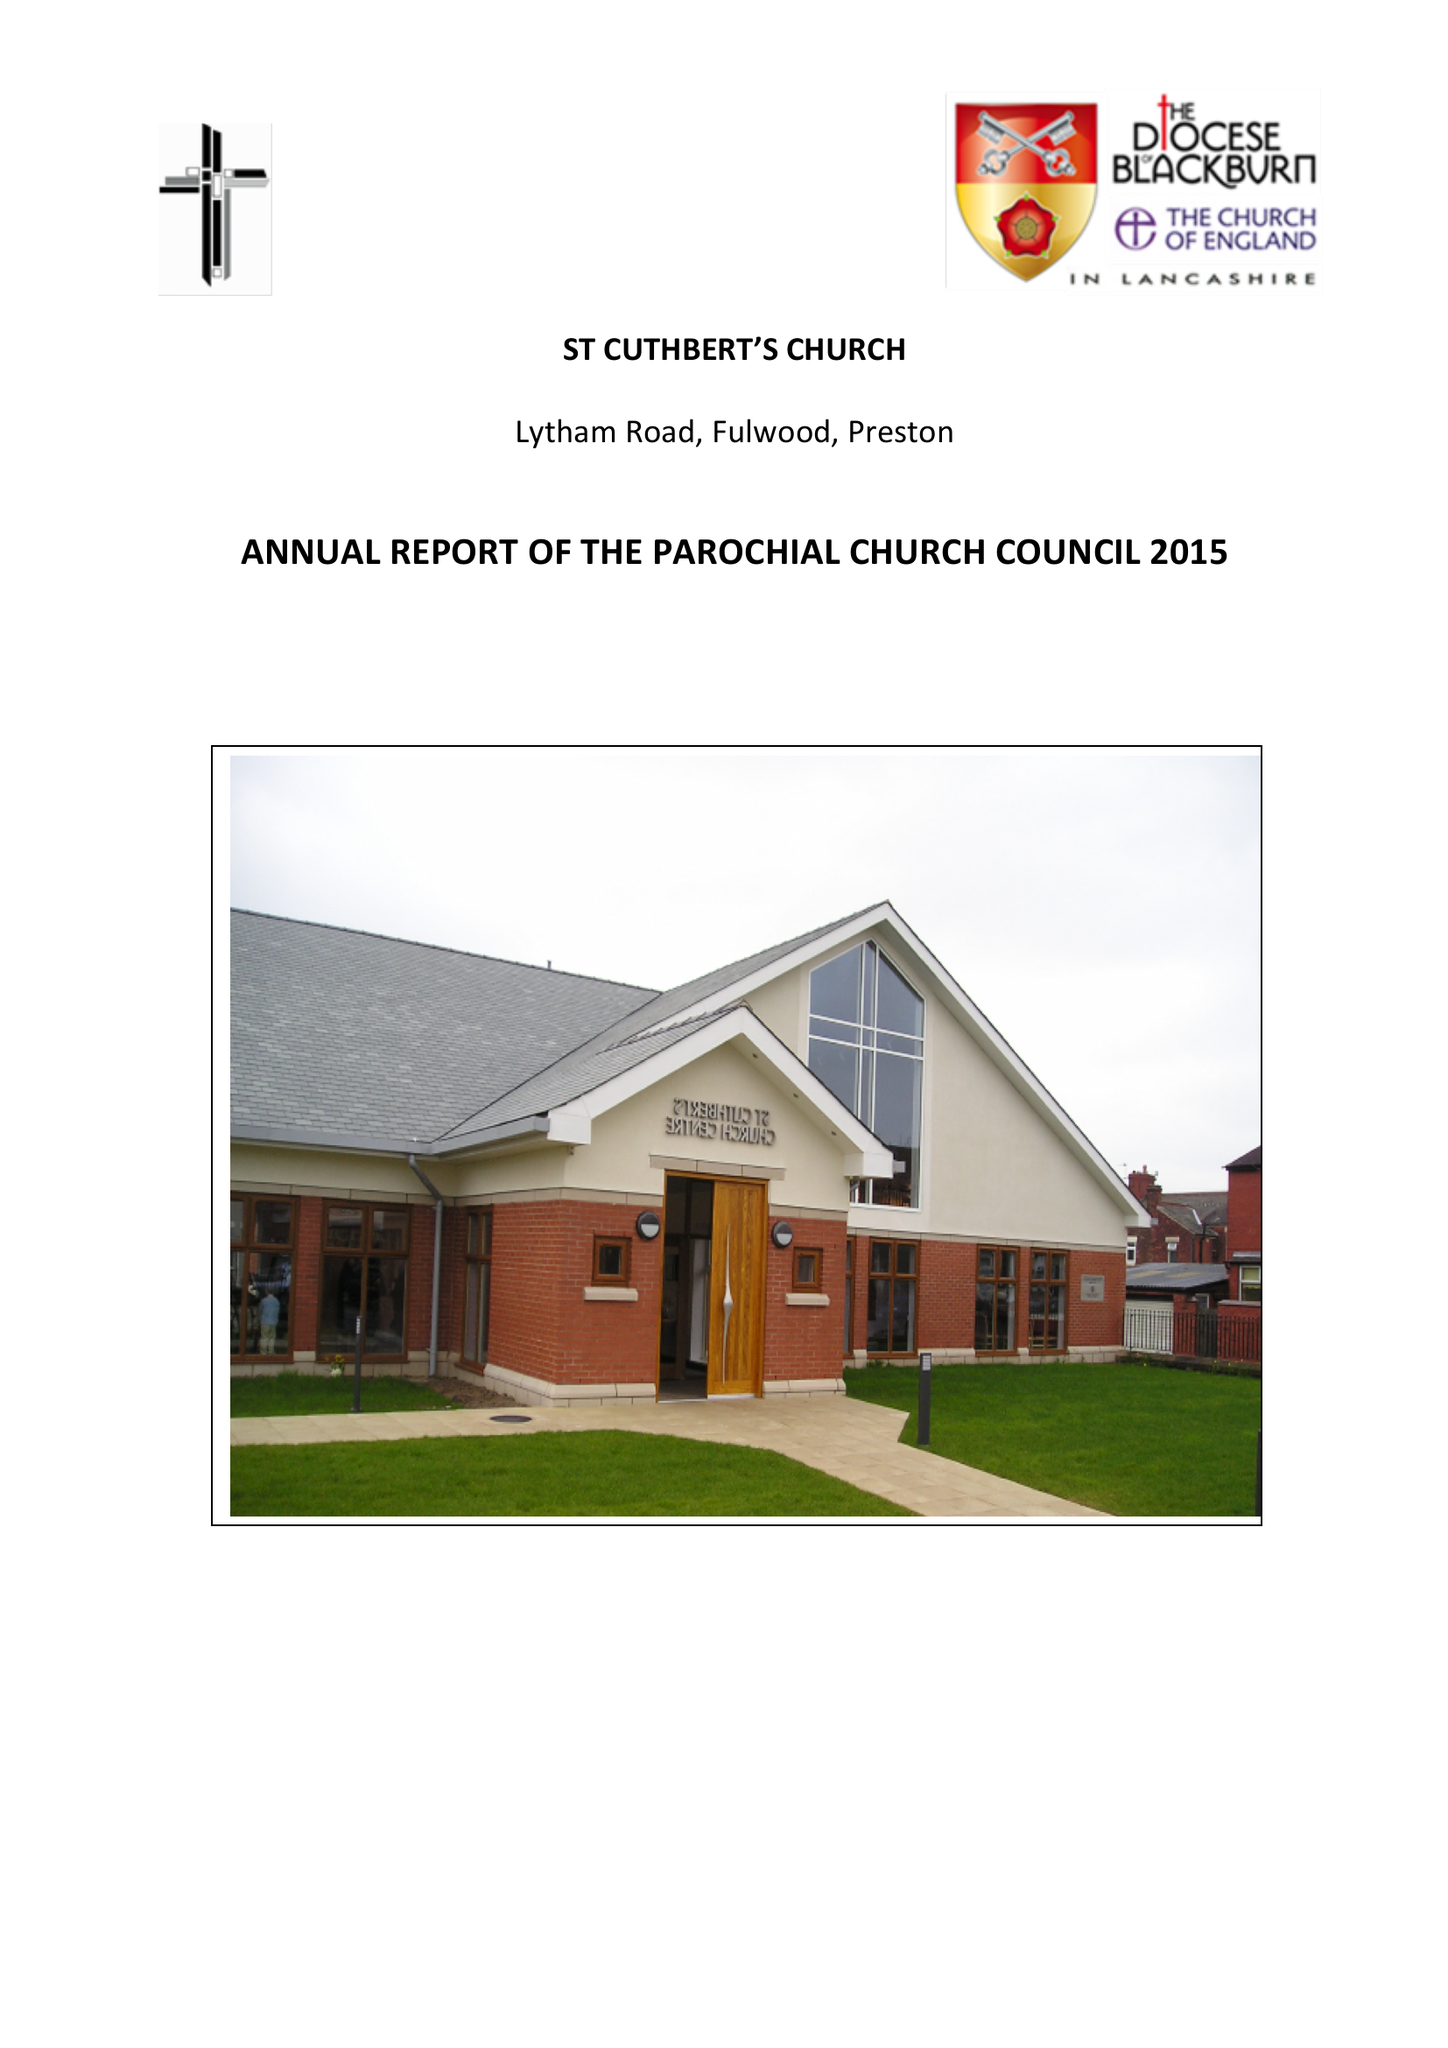What is the value for the address__postcode?
Answer the question using a single word or phrase. PR2 3AP 